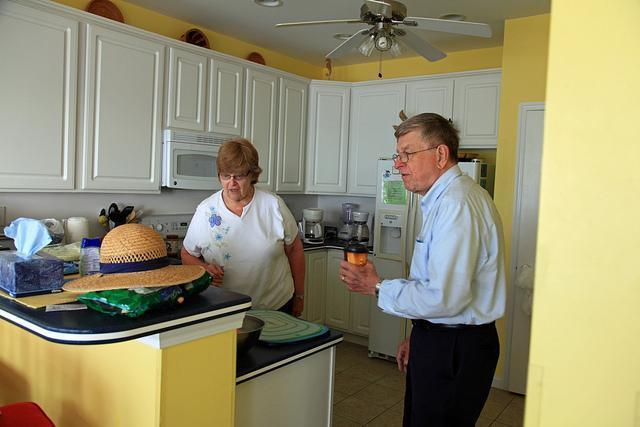How many girls are in this picture?
Give a very brief answer. 1. How many people are in the photo?
Give a very brief answer. 2. 